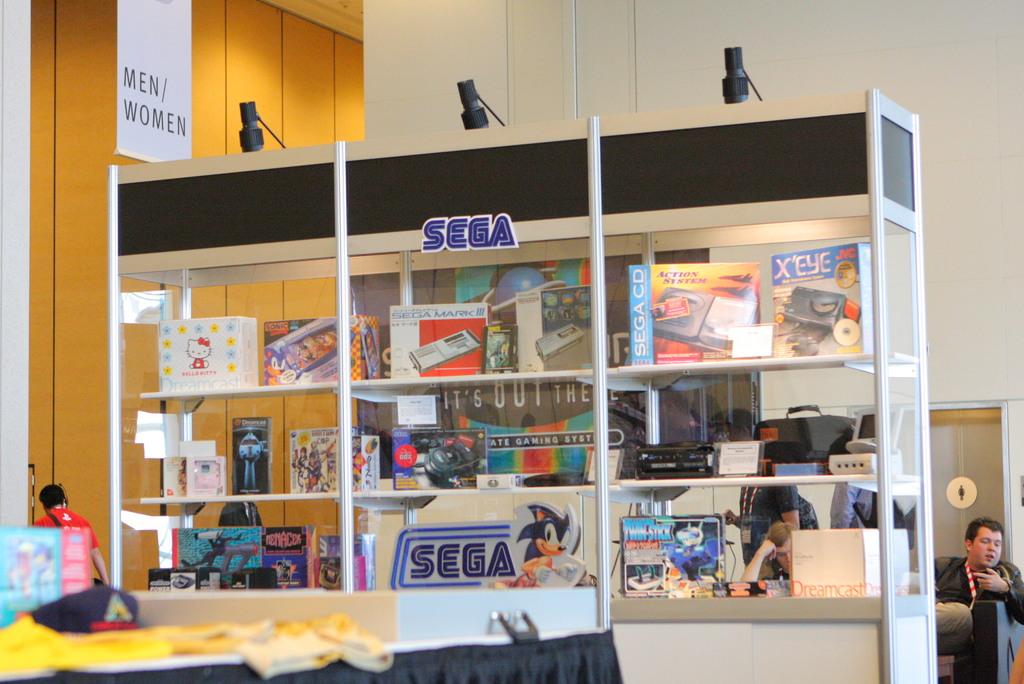What is the name of the video game company in blue?
Ensure brevity in your answer.  Sega. What does the white sing say?
Give a very brief answer. Men/women. 